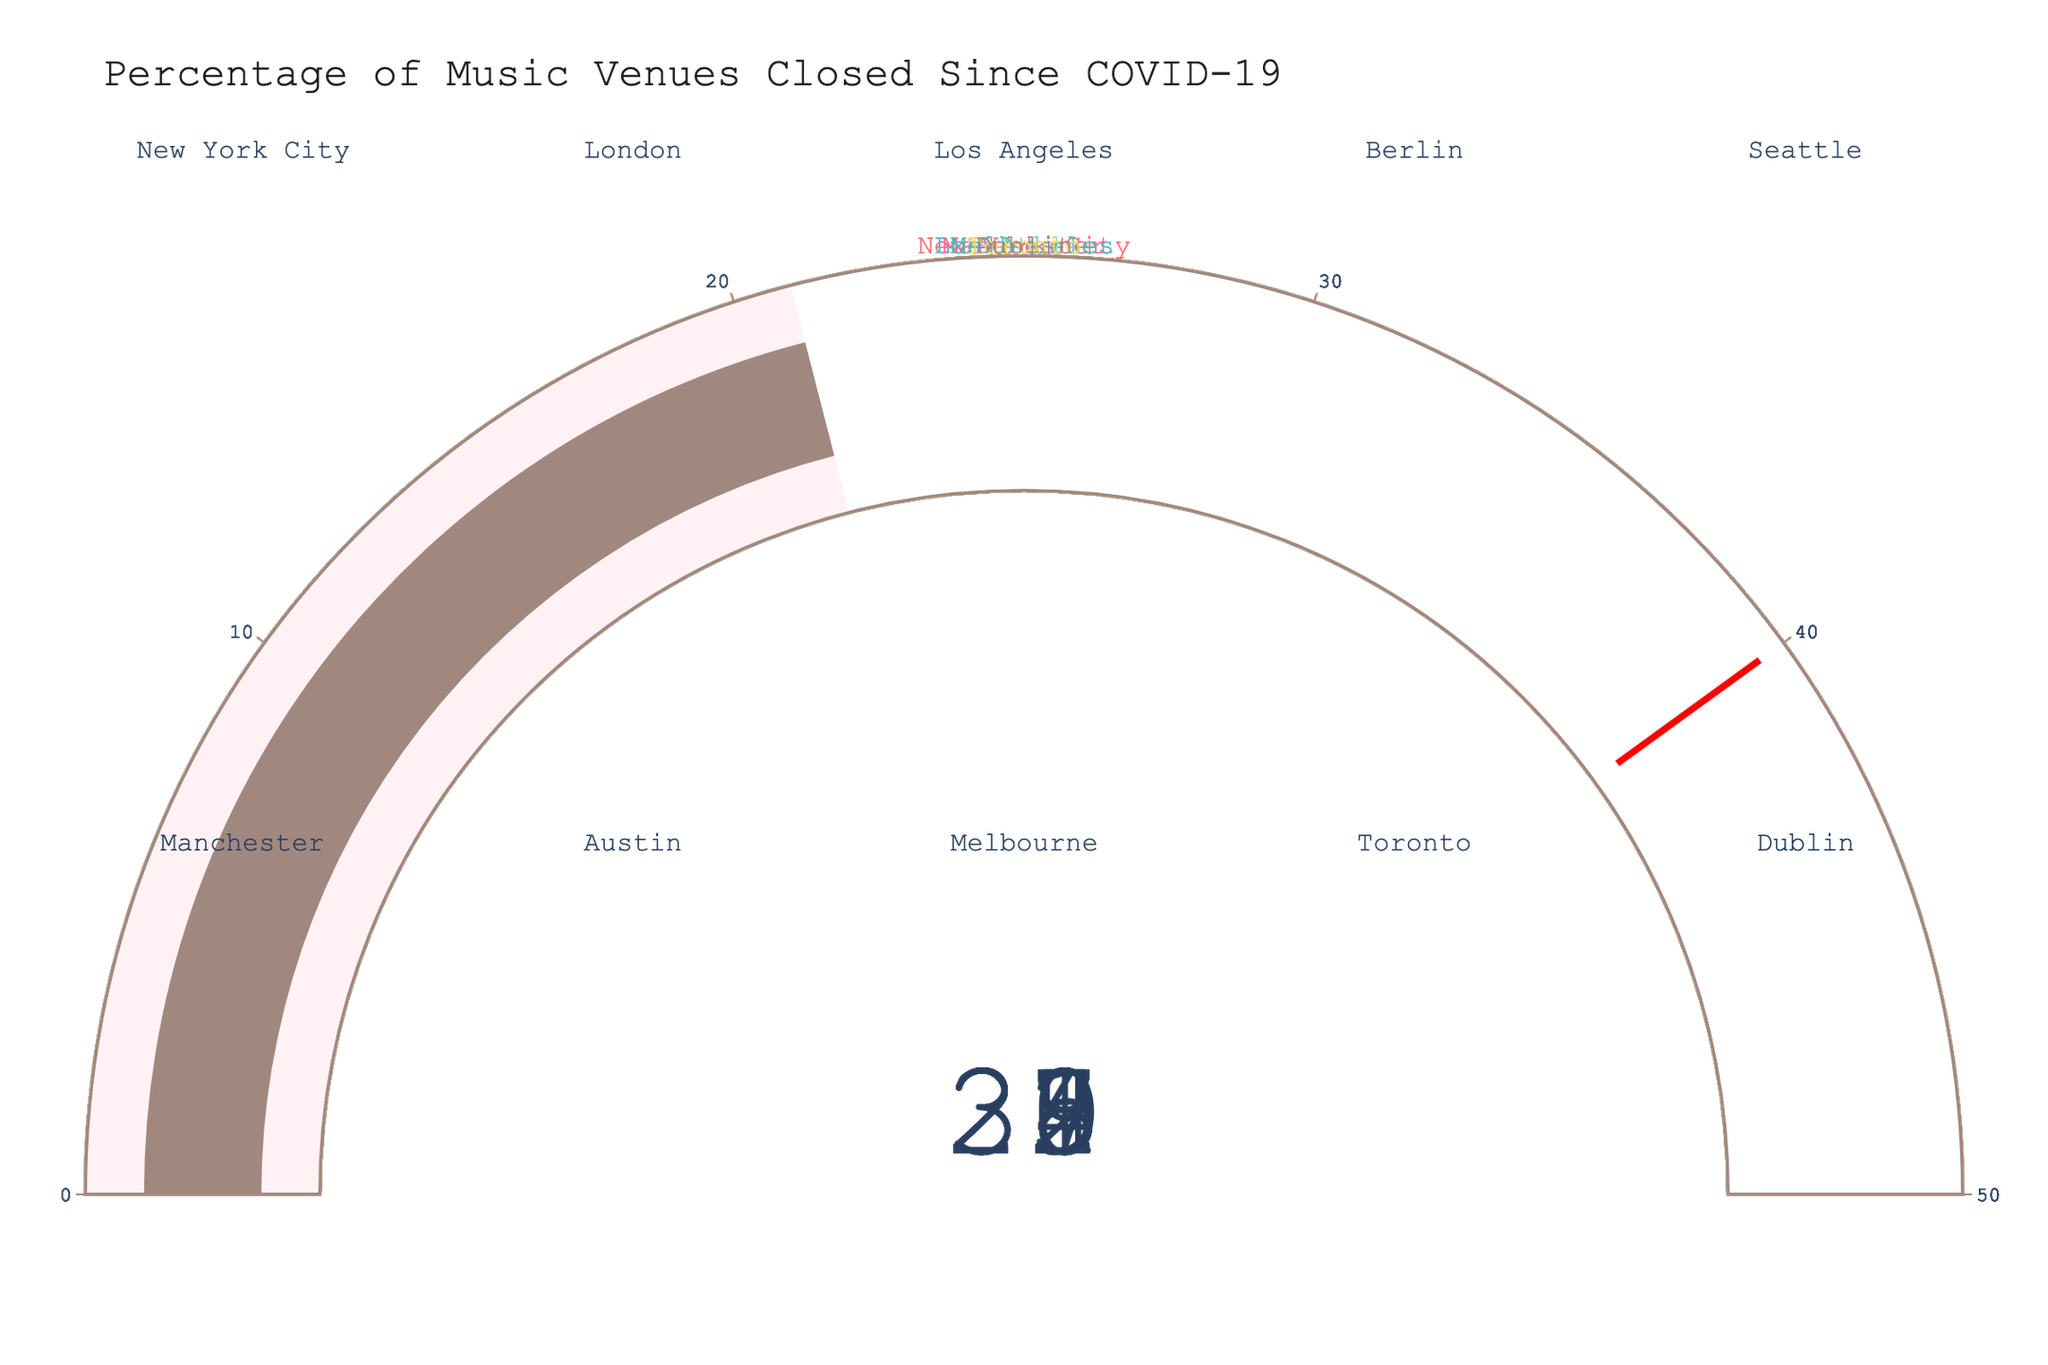What's the percentage of music venues that closed in Los Angeles? Look at the gauge for Los Angeles on the figure. The number displayed on the gauge is 35, which indicates the percentage of music venues that closed.
Answer: 35% Which city has the lowest percentage of music venue closures? Find the gauge with the smallest value. The lowest percentage on the figure is 21, which corresponds to Dublin.
Answer: Dublin What is the average percentage of closed music venues for New York City, London, and Berlin? Sum the percentages of New York City (32), London (28), and Berlin (30), then divide by 3. The calculation is (32 + 28 + 30) / 3.
Answer: 30 Between Seattle and Austin, which city witnessed a higher percentage of music venue closures, and by how much? Seattle has 25%, and Austin has 29%. Subtract Seattle's percentage from Austin's. The difference is 29 - 25.
Answer: Austin by 4% What is the median percentage of music venues closed among all the cities? List the percentages: 21, 22, 24, 25, 27, 28, 29, 30, 32, 35. The middle values are 27 and 28, so the median is (27 + 28) / 2.
Answer: 27.5 Which city had more closures, Melbourne or Manchester? Compare the percentages for Melbourne (27) and Manchester (22). Melbourne has a higher percentage of closures.
Answer: Melbourne What is the total percentage of music venue closures for all the cities combined? Add all the percentages: 32 + 28 + 35 + 30 + 25 + 22 + 29 + 27 + 24 + 21. The sum is 273.
Answer: 273% Are there any cities where the percentage of closures was at least 30%? Identify gauges with values of 30 or more: New York City (32), Los Angeles (35), and Berlin (30).
Answer: Yes Which city's gauge indicates a value closest to 25%? Search for the gauge with a value closest to 25%. Seattle has a gauge showing 25%.
Answer: Seattle 